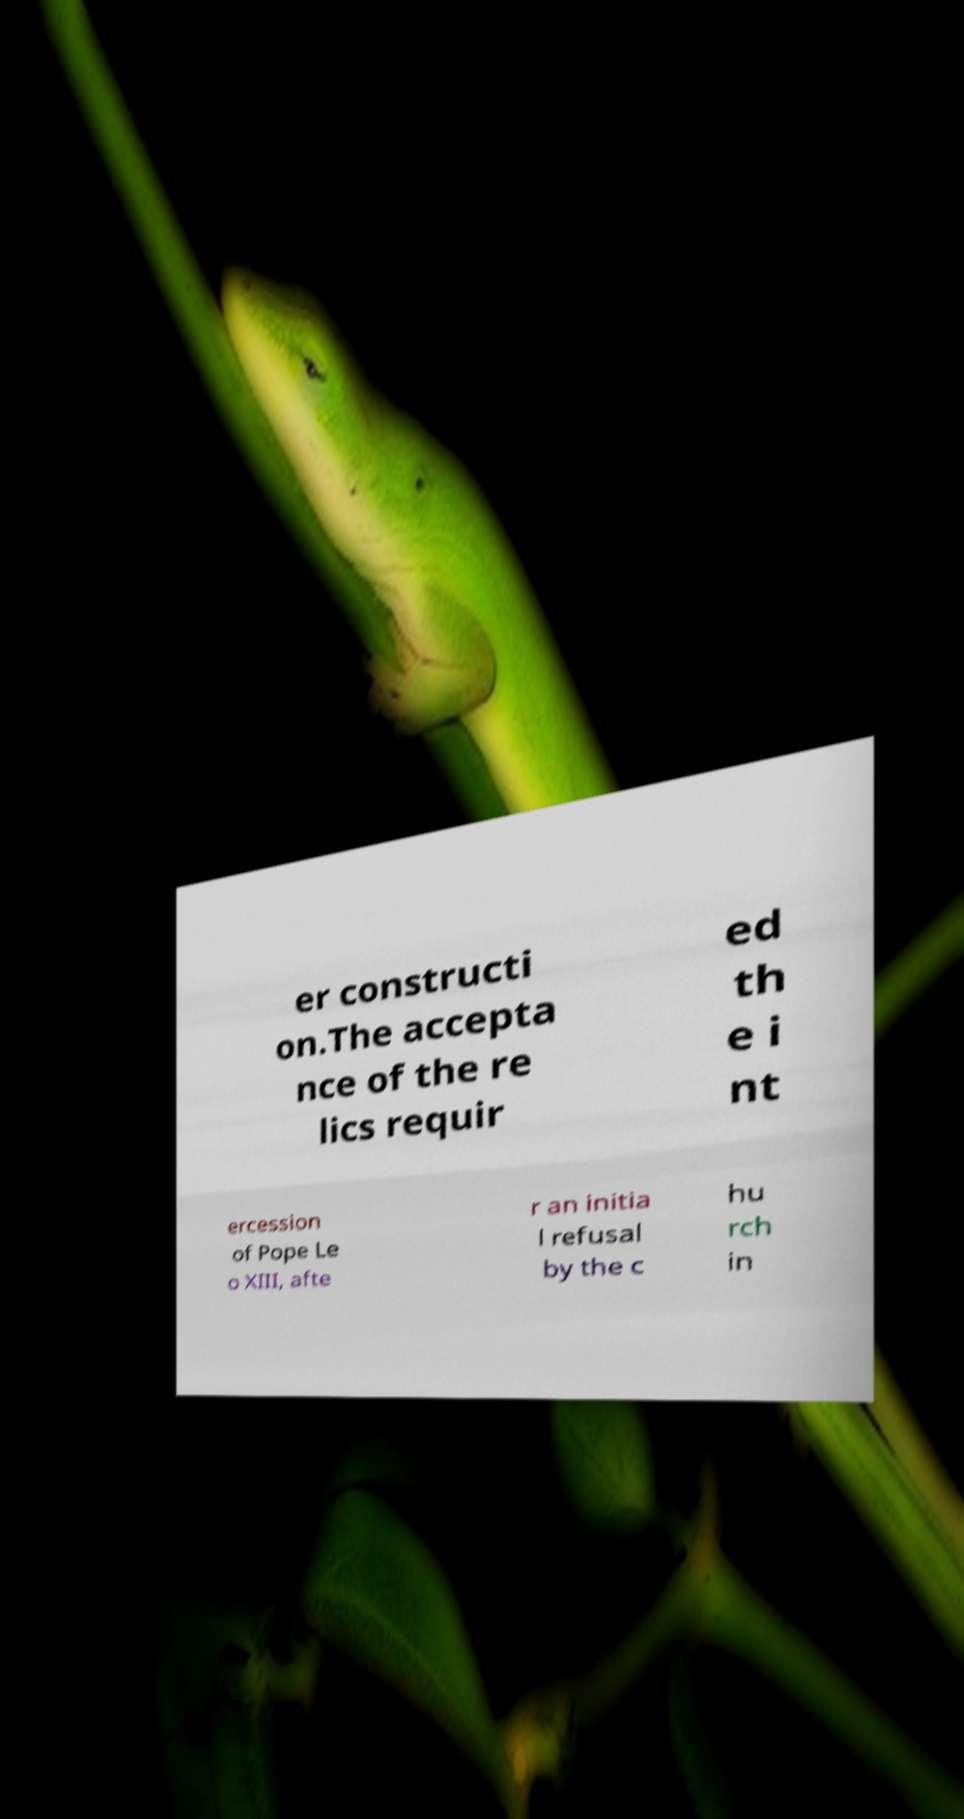Could you assist in decoding the text presented in this image and type it out clearly? er constructi on.The accepta nce of the re lics requir ed th e i nt ercession of Pope Le o XIII, afte r an initia l refusal by the c hu rch in 